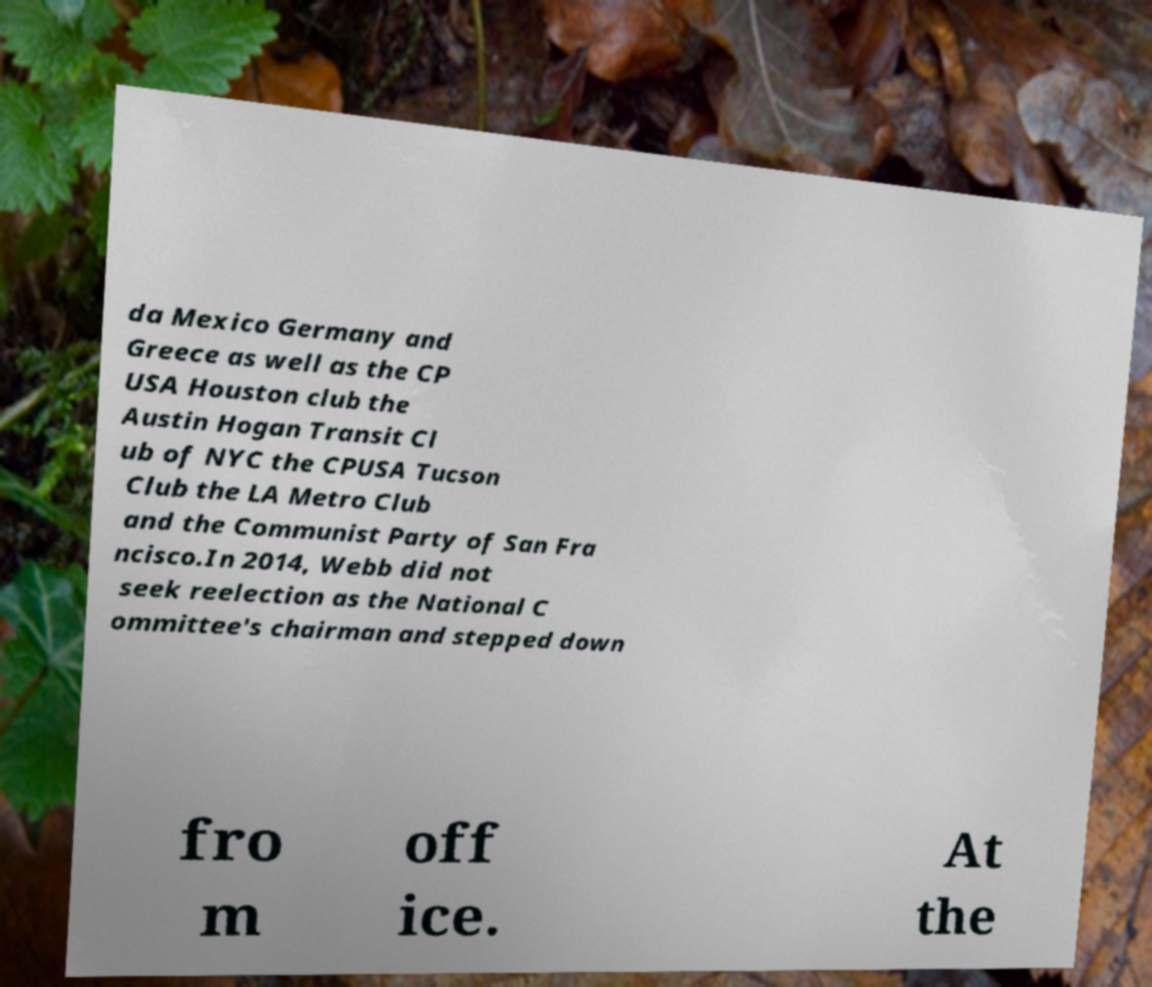Please identify and transcribe the text found in this image. da Mexico Germany and Greece as well as the CP USA Houston club the Austin Hogan Transit Cl ub of NYC the CPUSA Tucson Club the LA Metro Club and the Communist Party of San Fra ncisco.In 2014, Webb did not seek reelection as the National C ommittee's chairman and stepped down fro m off ice. At the 